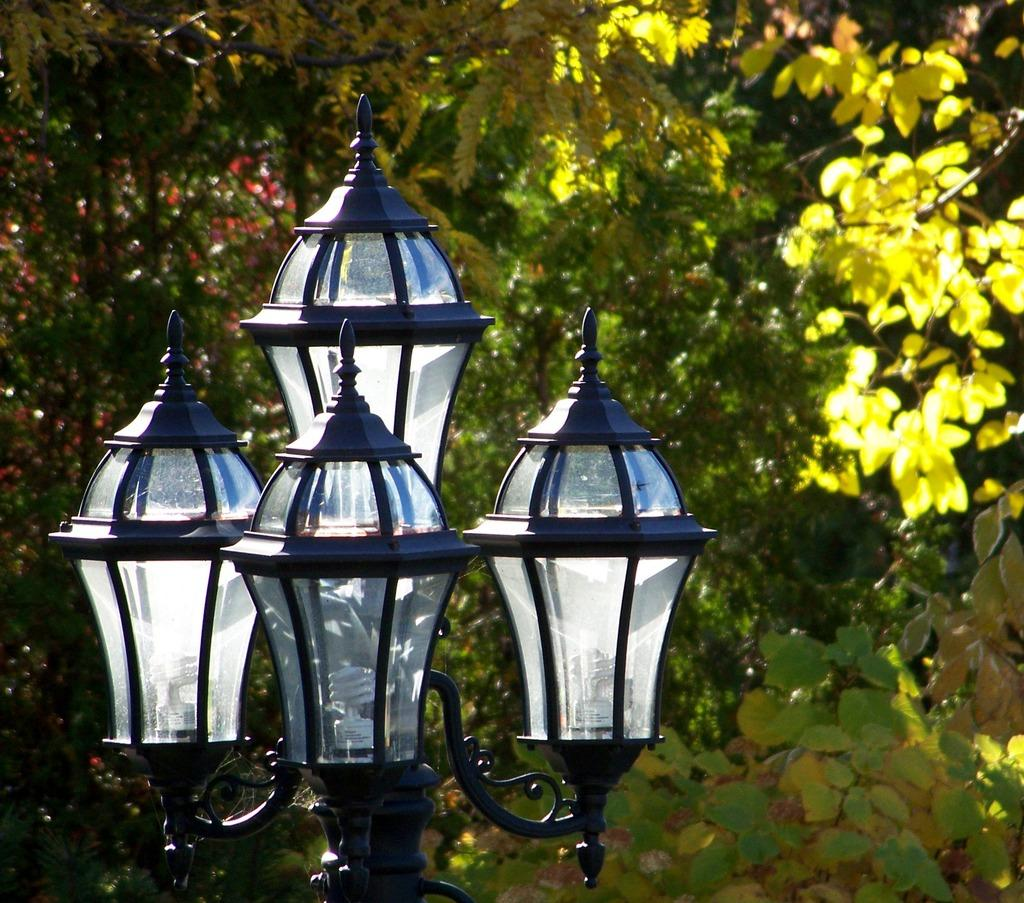What type of lighting can be seen in the image? There are street lights in the image. What can be seen in the background of the image? There are trees and plants in the background of the image. Can you describe the vegetation on the right side of the image? There are leaves visible on the right side of the image. What type of cracker is being distributed in the image? There is no cracker or distribution present in the image. What book can be seen on the left side of the image? There is no book visible in the image. 